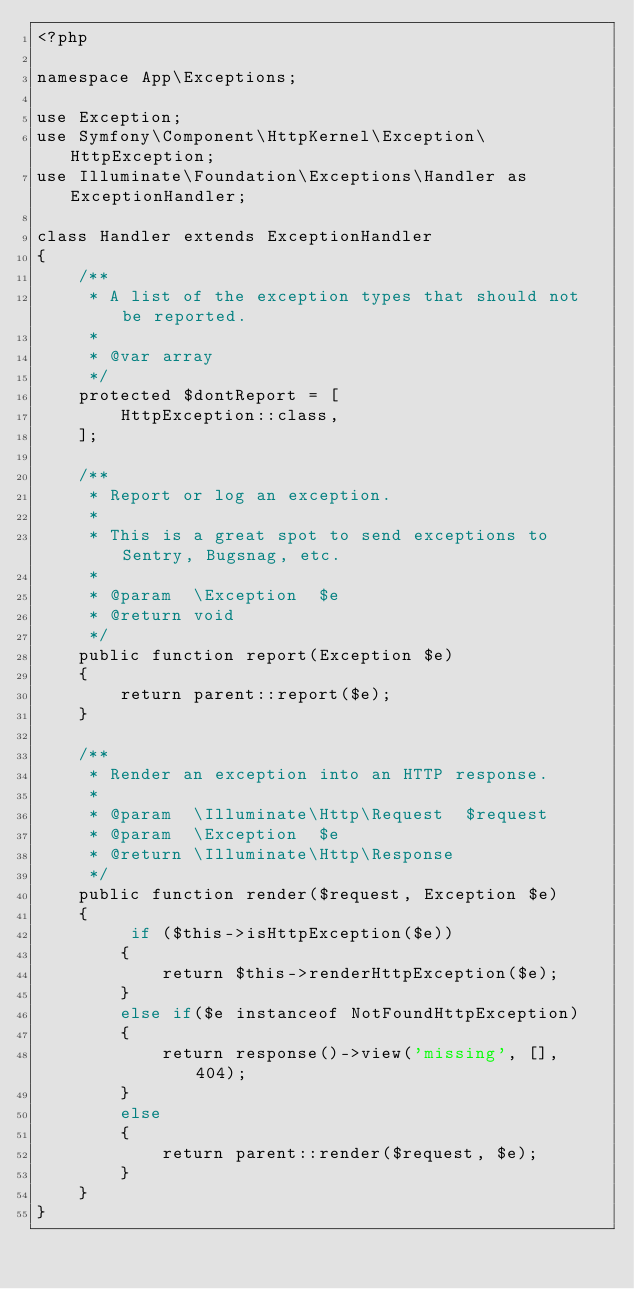<code> <loc_0><loc_0><loc_500><loc_500><_PHP_><?php

namespace App\Exceptions;

use Exception;
use Symfony\Component\HttpKernel\Exception\HttpException;
use Illuminate\Foundation\Exceptions\Handler as ExceptionHandler;

class Handler extends ExceptionHandler
{
    /**
     * A list of the exception types that should not be reported.
     *
     * @var array
     */
    protected $dontReport = [
        HttpException::class,
    ];

    /**
     * Report or log an exception.
     *
     * This is a great spot to send exceptions to Sentry, Bugsnag, etc.
     *
     * @param  \Exception  $e
     * @return void
     */
    public function report(Exception $e)
    {
        return parent::report($e);
    }

    /**
     * Render an exception into an HTTP response.
     *
     * @param  \Illuminate\Http\Request  $request
     * @param  \Exception  $e
     * @return \Illuminate\Http\Response
     */
    public function render($request, Exception $e)
    {
         if ($this->isHttpException($e))
        {
            return $this->renderHttpException($e);
        }
        else if($e instanceof NotFoundHttpException)
        {
            return response()->view('missing', [], 404);
        }
        else
        {
            return parent::render($request, $e);
        }
    }
}
</code> 